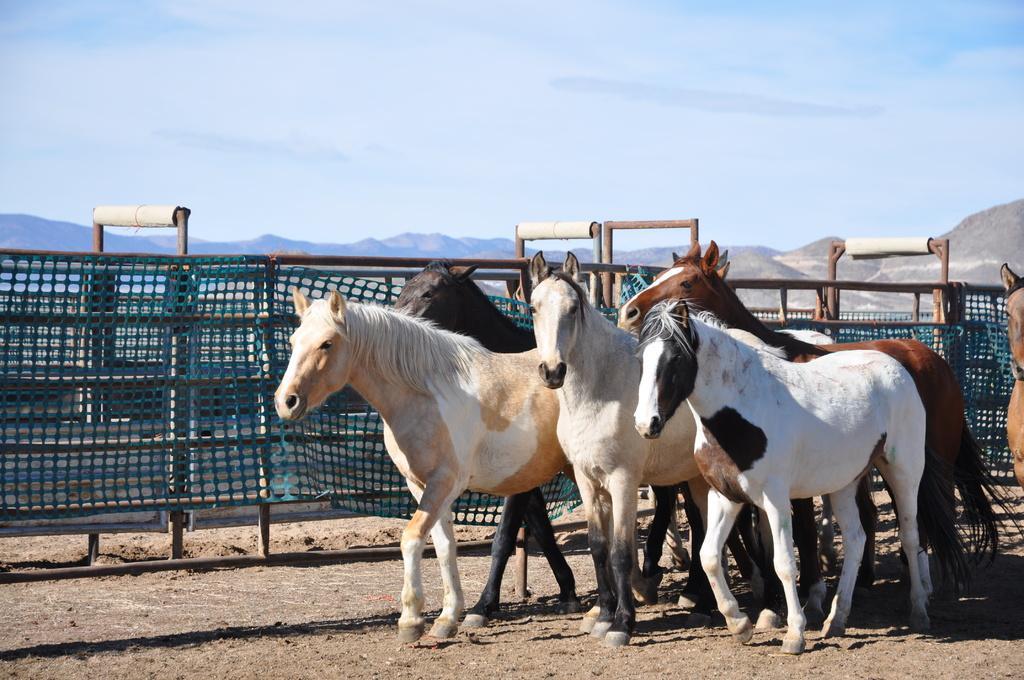Please provide a concise description of this image. In this picture, there are group of horses at the bottom right. The horses are in different colors. Behind them, there is a fence. In the background, there are hills and sky. 